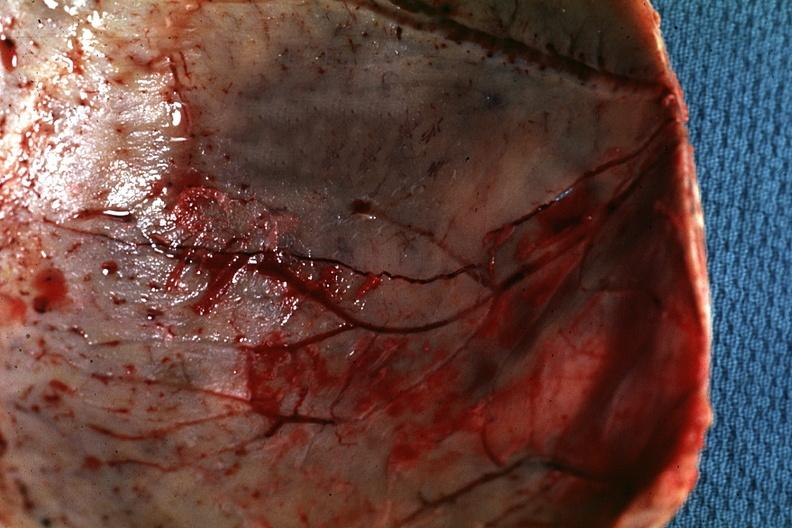does cervical leiomyoma show fracture line well shown very thin skull eggshell type?
Answer the question using a single word or phrase. No 